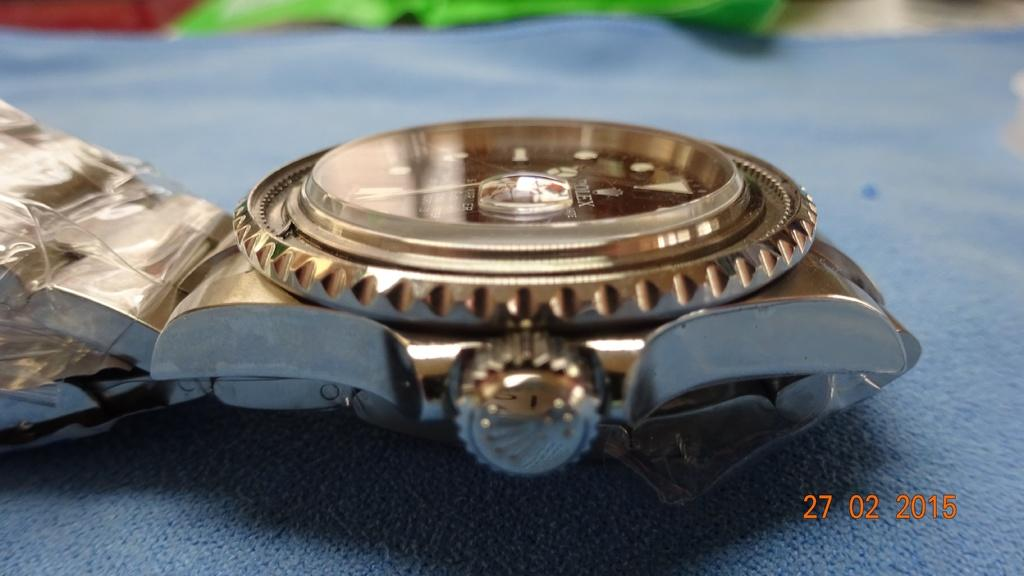<image>
Summarize the visual content of the image. A side view gold wristwatch on a blue surface from 2015. 